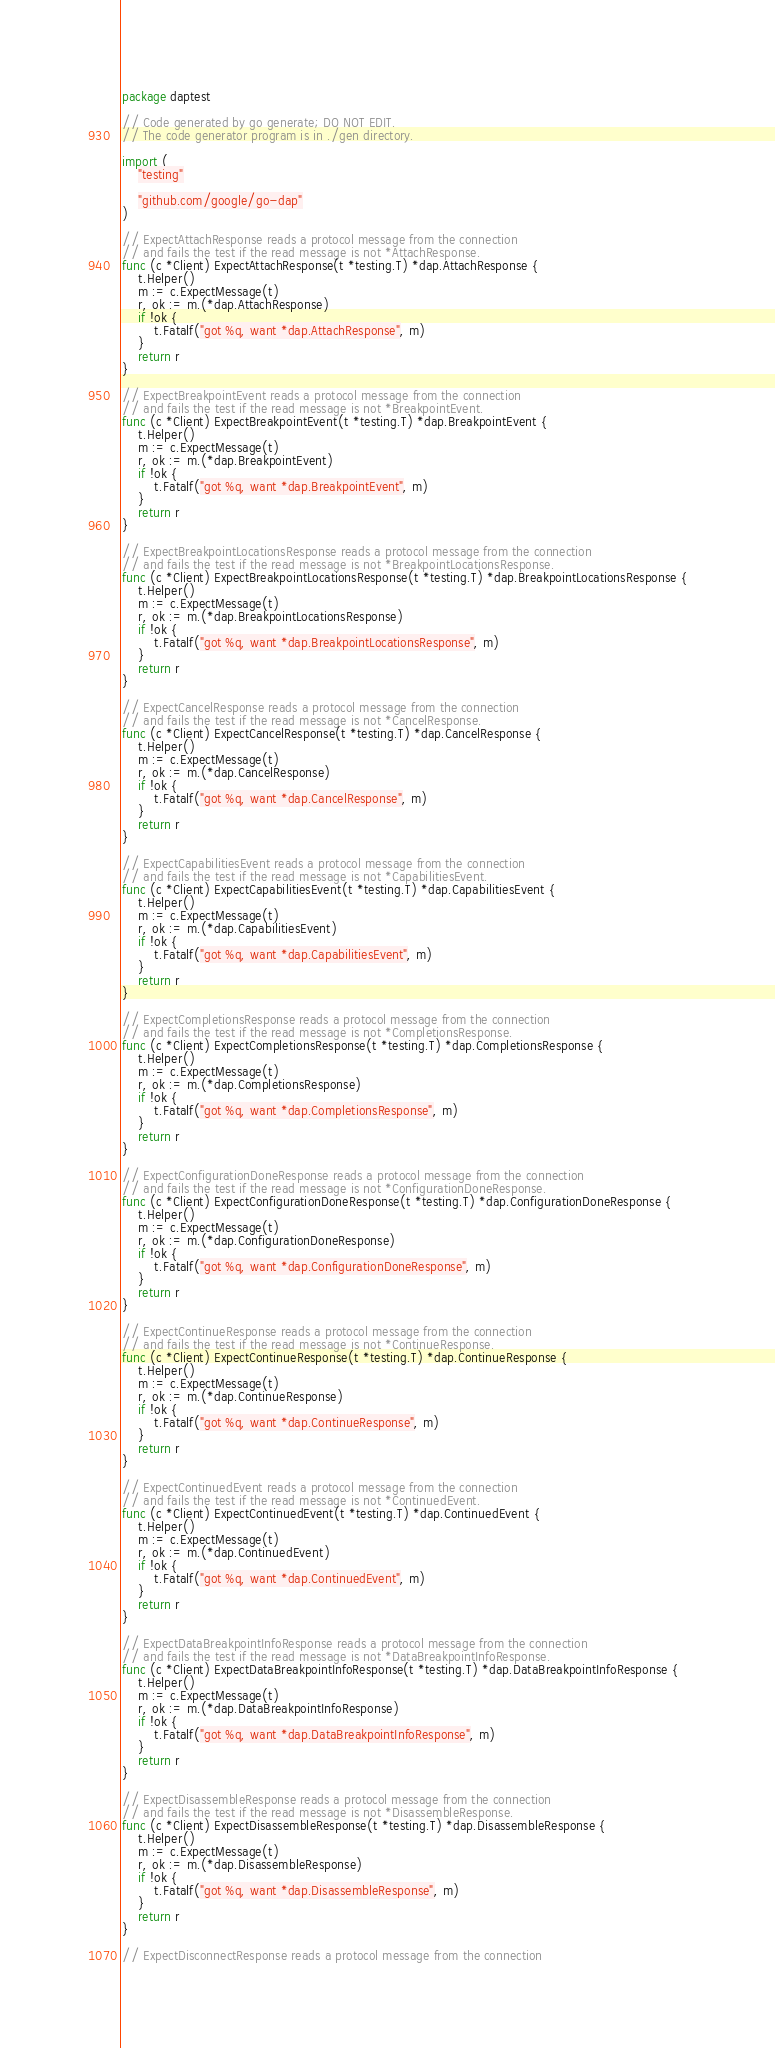Convert code to text. <code><loc_0><loc_0><loc_500><loc_500><_Go_>package daptest

// Code generated by go generate; DO NOT EDIT.
// The code generator program is in ./gen directory.

import (
	"testing"

	"github.com/google/go-dap"
)

// ExpectAttachResponse reads a protocol message from the connection
// and fails the test if the read message is not *AttachResponse.
func (c *Client) ExpectAttachResponse(t *testing.T) *dap.AttachResponse {
	t.Helper()
	m := c.ExpectMessage(t)
	r, ok := m.(*dap.AttachResponse)
	if !ok {
		t.Fatalf("got %q, want *dap.AttachResponse", m)
	}
	return r
}

// ExpectBreakpointEvent reads a protocol message from the connection
// and fails the test if the read message is not *BreakpointEvent.
func (c *Client) ExpectBreakpointEvent(t *testing.T) *dap.BreakpointEvent {
	t.Helper()
	m := c.ExpectMessage(t)
	r, ok := m.(*dap.BreakpointEvent)
	if !ok {
		t.Fatalf("got %q, want *dap.BreakpointEvent", m)
	}
	return r
}

// ExpectBreakpointLocationsResponse reads a protocol message from the connection
// and fails the test if the read message is not *BreakpointLocationsResponse.
func (c *Client) ExpectBreakpointLocationsResponse(t *testing.T) *dap.BreakpointLocationsResponse {
	t.Helper()
	m := c.ExpectMessage(t)
	r, ok := m.(*dap.BreakpointLocationsResponse)
	if !ok {
		t.Fatalf("got %q, want *dap.BreakpointLocationsResponse", m)
	}
	return r
}

// ExpectCancelResponse reads a protocol message from the connection
// and fails the test if the read message is not *CancelResponse.
func (c *Client) ExpectCancelResponse(t *testing.T) *dap.CancelResponse {
	t.Helper()
	m := c.ExpectMessage(t)
	r, ok := m.(*dap.CancelResponse)
	if !ok {
		t.Fatalf("got %q, want *dap.CancelResponse", m)
	}
	return r
}

// ExpectCapabilitiesEvent reads a protocol message from the connection
// and fails the test if the read message is not *CapabilitiesEvent.
func (c *Client) ExpectCapabilitiesEvent(t *testing.T) *dap.CapabilitiesEvent {
	t.Helper()
	m := c.ExpectMessage(t)
	r, ok := m.(*dap.CapabilitiesEvent)
	if !ok {
		t.Fatalf("got %q, want *dap.CapabilitiesEvent", m)
	}
	return r
}

// ExpectCompletionsResponse reads a protocol message from the connection
// and fails the test if the read message is not *CompletionsResponse.
func (c *Client) ExpectCompletionsResponse(t *testing.T) *dap.CompletionsResponse {
	t.Helper()
	m := c.ExpectMessage(t)
	r, ok := m.(*dap.CompletionsResponse)
	if !ok {
		t.Fatalf("got %q, want *dap.CompletionsResponse", m)
	}
	return r
}

// ExpectConfigurationDoneResponse reads a protocol message from the connection
// and fails the test if the read message is not *ConfigurationDoneResponse.
func (c *Client) ExpectConfigurationDoneResponse(t *testing.T) *dap.ConfigurationDoneResponse {
	t.Helper()
	m := c.ExpectMessage(t)
	r, ok := m.(*dap.ConfigurationDoneResponse)
	if !ok {
		t.Fatalf("got %q, want *dap.ConfigurationDoneResponse", m)
	}
	return r
}

// ExpectContinueResponse reads a protocol message from the connection
// and fails the test if the read message is not *ContinueResponse.
func (c *Client) ExpectContinueResponse(t *testing.T) *dap.ContinueResponse {
	t.Helper()
	m := c.ExpectMessage(t)
	r, ok := m.(*dap.ContinueResponse)
	if !ok {
		t.Fatalf("got %q, want *dap.ContinueResponse", m)
	}
	return r
}

// ExpectContinuedEvent reads a protocol message from the connection
// and fails the test if the read message is not *ContinuedEvent.
func (c *Client) ExpectContinuedEvent(t *testing.T) *dap.ContinuedEvent {
	t.Helper()
	m := c.ExpectMessage(t)
	r, ok := m.(*dap.ContinuedEvent)
	if !ok {
		t.Fatalf("got %q, want *dap.ContinuedEvent", m)
	}
	return r
}

// ExpectDataBreakpointInfoResponse reads a protocol message from the connection
// and fails the test if the read message is not *DataBreakpointInfoResponse.
func (c *Client) ExpectDataBreakpointInfoResponse(t *testing.T) *dap.DataBreakpointInfoResponse {
	t.Helper()
	m := c.ExpectMessage(t)
	r, ok := m.(*dap.DataBreakpointInfoResponse)
	if !ok {
		t.Fatalf("got %q, want *dap.DataBreakpointInfoResponse", m)
	}
	return r
}

// ExpectDisassembleResponse reads a protocol message from the connection
// and fails the test if the read message is not *DisassembleResponse.
func (c *Client) ExpectDisassembleResponse(t *testing.T) *dap.DisassembleResponse {
	t.Helper()
	m := c.ExpectMessage(t)
	r, ok := m.(*dap.DisassembleResponse)
	if !ok {
		t.Fatalf("got %q, want *dap.DisassembleResponse", m)
	}
	return r
}

// ExpectDisconnectResponse reads a protocol message from the connection</code> 